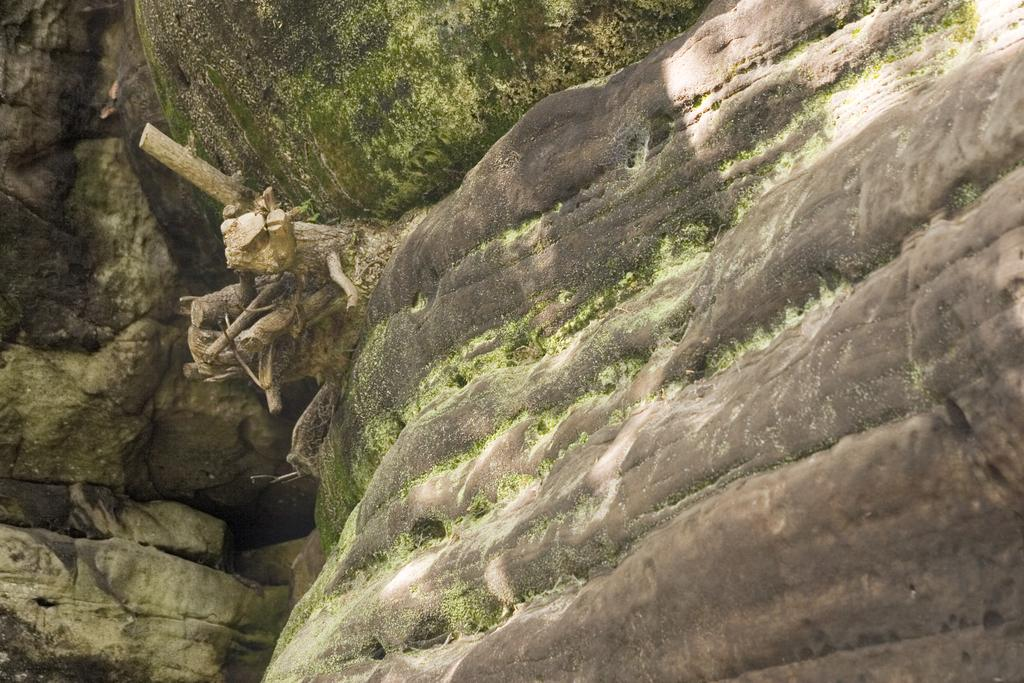What type of natural formation can be seen in the image? There are rocks in the image. What is growing on the rocks? Algae is visible on the rocks. What other object is present in the image? There is a wooden tree trunk in the image. How has the wooden tree trunk been modified? The wooden tree trunk is cut. What type of relation is depicted between the rocks and the wooden tree trunk in the image? There is no depiction of a relation between the rocks and the wooden tree trunk in the image; they are separate objects. 